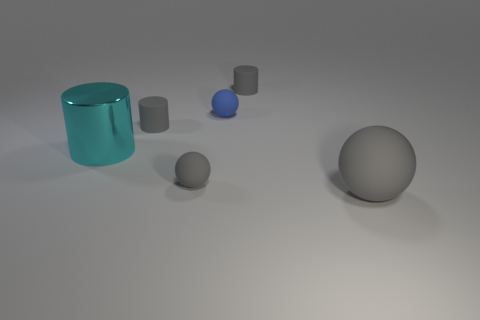Do the large matte ball and the tiny matte sphere that is in front of the small blue rubber object have the same color?
Offer a very short reply. Yes. Is the number of large rubber spheres greater than the number of brown spheres?
Your answer should be very brief. Yes. What color is the shiny thing?
Ensure brevity in your answer.  Cyan. There is a tiny object right of the blue matte thing; is it the same color as the large ball?
Give a very brief answer. Yes. How many cylinders have the same color as the large sphere?
Your answer should be compact. 2. There is a tiny matte object that is in front of the metal object; is its shape the same as the blue thing?
Your answer should be very brief. Yes. Are there fewer small gray spheres in front of the cyan object than gray rubber things to the left of the blue rubber thing?
Make the answer very short. Yes. What material is the small object that is in front of the cyan metal object?
Your response must be concise. Rubber. Are there any other rubber objects that have the same size as the blue matte object?
Ensure brevity in your answer.  Yes. Is the shape of the blue object the same as the big thing in front of the metal cylinder?
Ensure brevity in your answer.  Yes. 